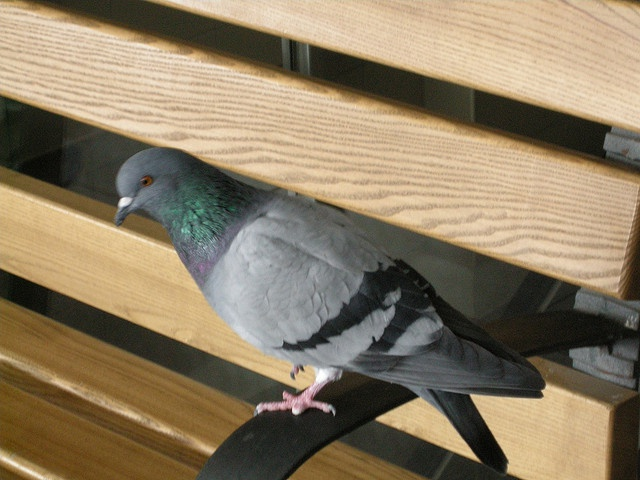Describe the objects in this image and their specific colors. I can see bench in gray, tan, and olive tones and bird in tan, gray, black, and darkgray tones in this image. 